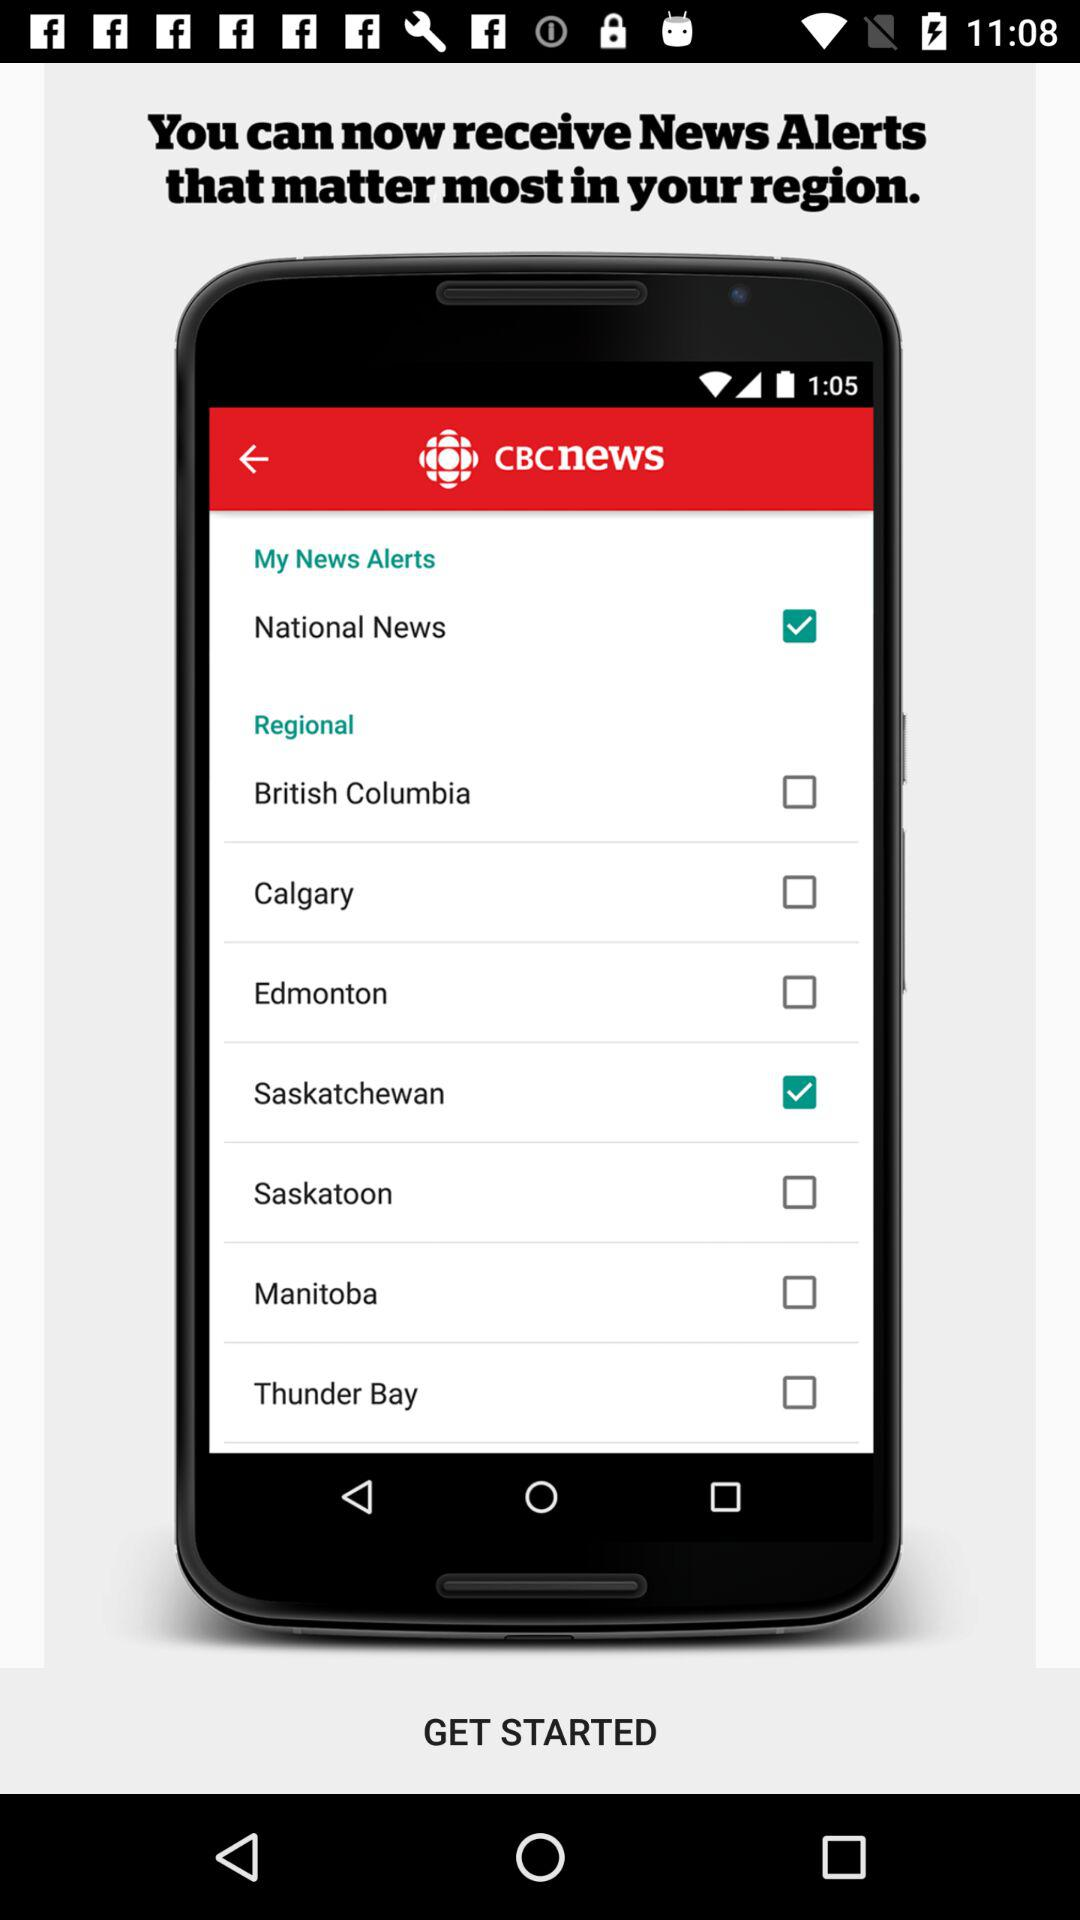Which region is checked? The checked region is Saskatchewan. 